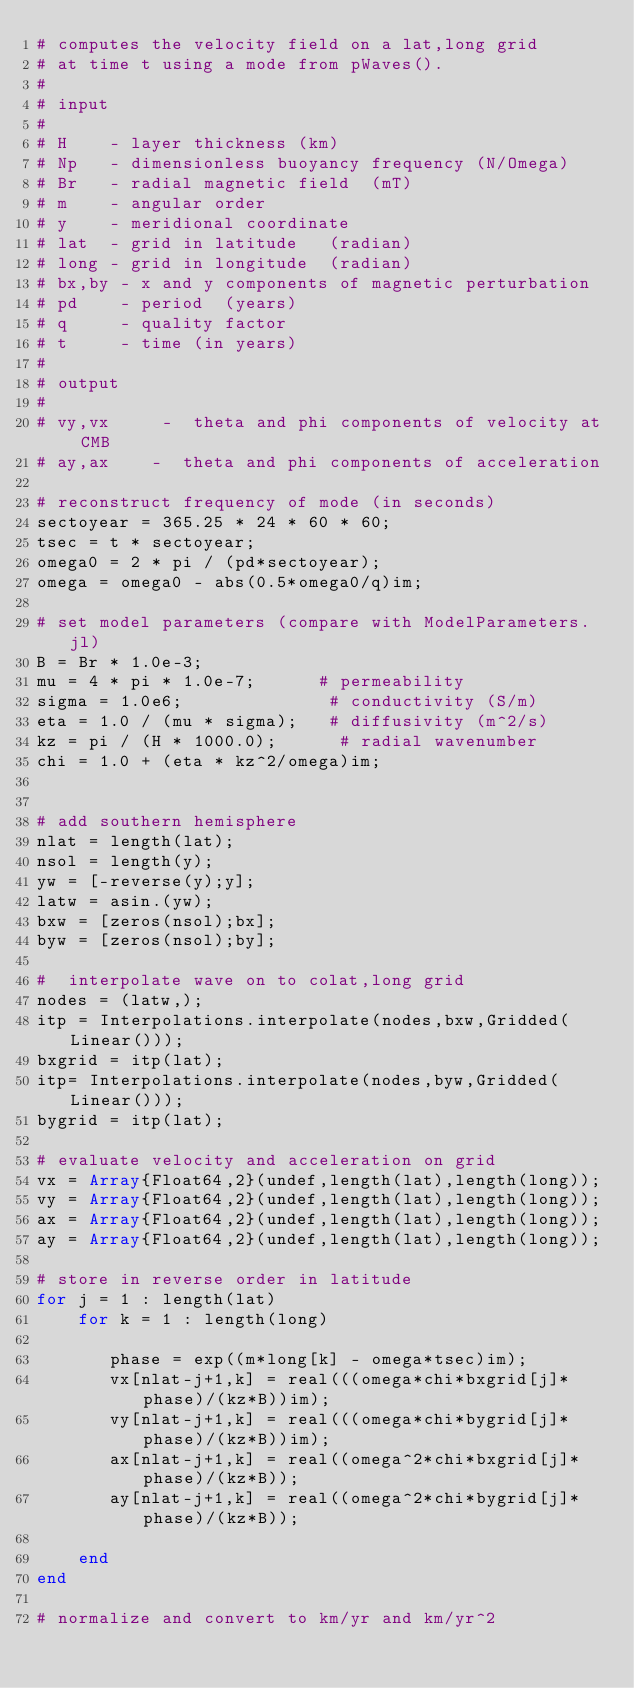Convert code to text. <code><loc_0><loc_0><loc_500><loc_500><_Julia_># computes the velocity field on a lat,long grid
# at time t using a mode from pWaves().
#
# input
#
# H    - layer thickness (km)
# Np   - dimensionless buoyancy frequency (N/Omega)
# Br   - radial magnetic field  (mT)
# m    - angular order
# y    - meridional coordinate
# lat  - grid in latitude   (radian)
# long - grid in longitude  (radian)
# bx,by - x and y components of magnetic perturbation
# pd    - period  (years)
# q     - quality factor
# t     - time (in years)
#
# output
#
# vy,vx     -  theta and phi components of velocity at CMB
# ay,ax    -  theta and phi components of acceleration

# reconstruct frequency of mode (in seconds)
sectoyear = 365.25 * 24 * 60 * 60;
tsec = t * sectoyear;
omega0 = 2 * pi / (pd*sectoyear);
omega = omega0 - abs(0.5*omega0/q)im;

# set model parameters (compare with ModelParameters.jl)
B = Br * 1.0e-3;
mu = 4 * pi * 1.0e-7;      # permeability
sigma = 1.0e6;              # conductivity (S/m)
eta = 1.0 / (mu * sigma);   # diffusivity (m^2/s)
kz = pi / (H * 1000.0);      # radial wavenumber
chi = 1.0 + (eta * kz^2/omega)im;


# add southern hemisphere
nlat = length(lat);
nsol = length(y);
yw = [-reverse(y);y];
latw = asin.(yw);
bxw = [zeros(nsol);bx];
byw = [zeros(nsol);by];

#  interpolate wave on to colat,long grid
nodes = (latw,);
itp = Interpolations.interpolate(nodes,bxw,Gridded(Linear()));
bxgrid = itp(lat);
itp= Interpolations.interpolate(nodes,byw,Gridded(Linear()));
bygrid = itp(lat);

# evaluate velocity and acceleration on grid
vx = Array{Float64,2}(undef,length(lat),length(long));
vy = Array{Float64,2}(undef,length(lat),length(long));
ax = Array{Float64,2}(undef,length(lat),length(long));
ay = Array{Float64,2}(undef,length(lat),length(long));

# store in reverse order in latitude
for j = 1 : length(lat)
    for k = 1 : length(long)

       phase = exp((m*long[k] - omega*tsec)im);
       vx[nlat-j+1,k] = real(((omega*chi*bxgrid[j]*phase)/(kz*B))im);
       vy[nlat-j+1,k] = real(((omega*chi*bygrid[j]*phase)/(kz*B))im);
       ax[nlat-j+1,k] = real((omega^2*chi*bxgrid[j]*phase)/(kz*B));
       ay[nlat-j+1,k] = real((omega^2*chi*bygrid[j]*phase)/(kz*B));

    end
end

# normalize and convert to km/yr and km/yr^2</code> 